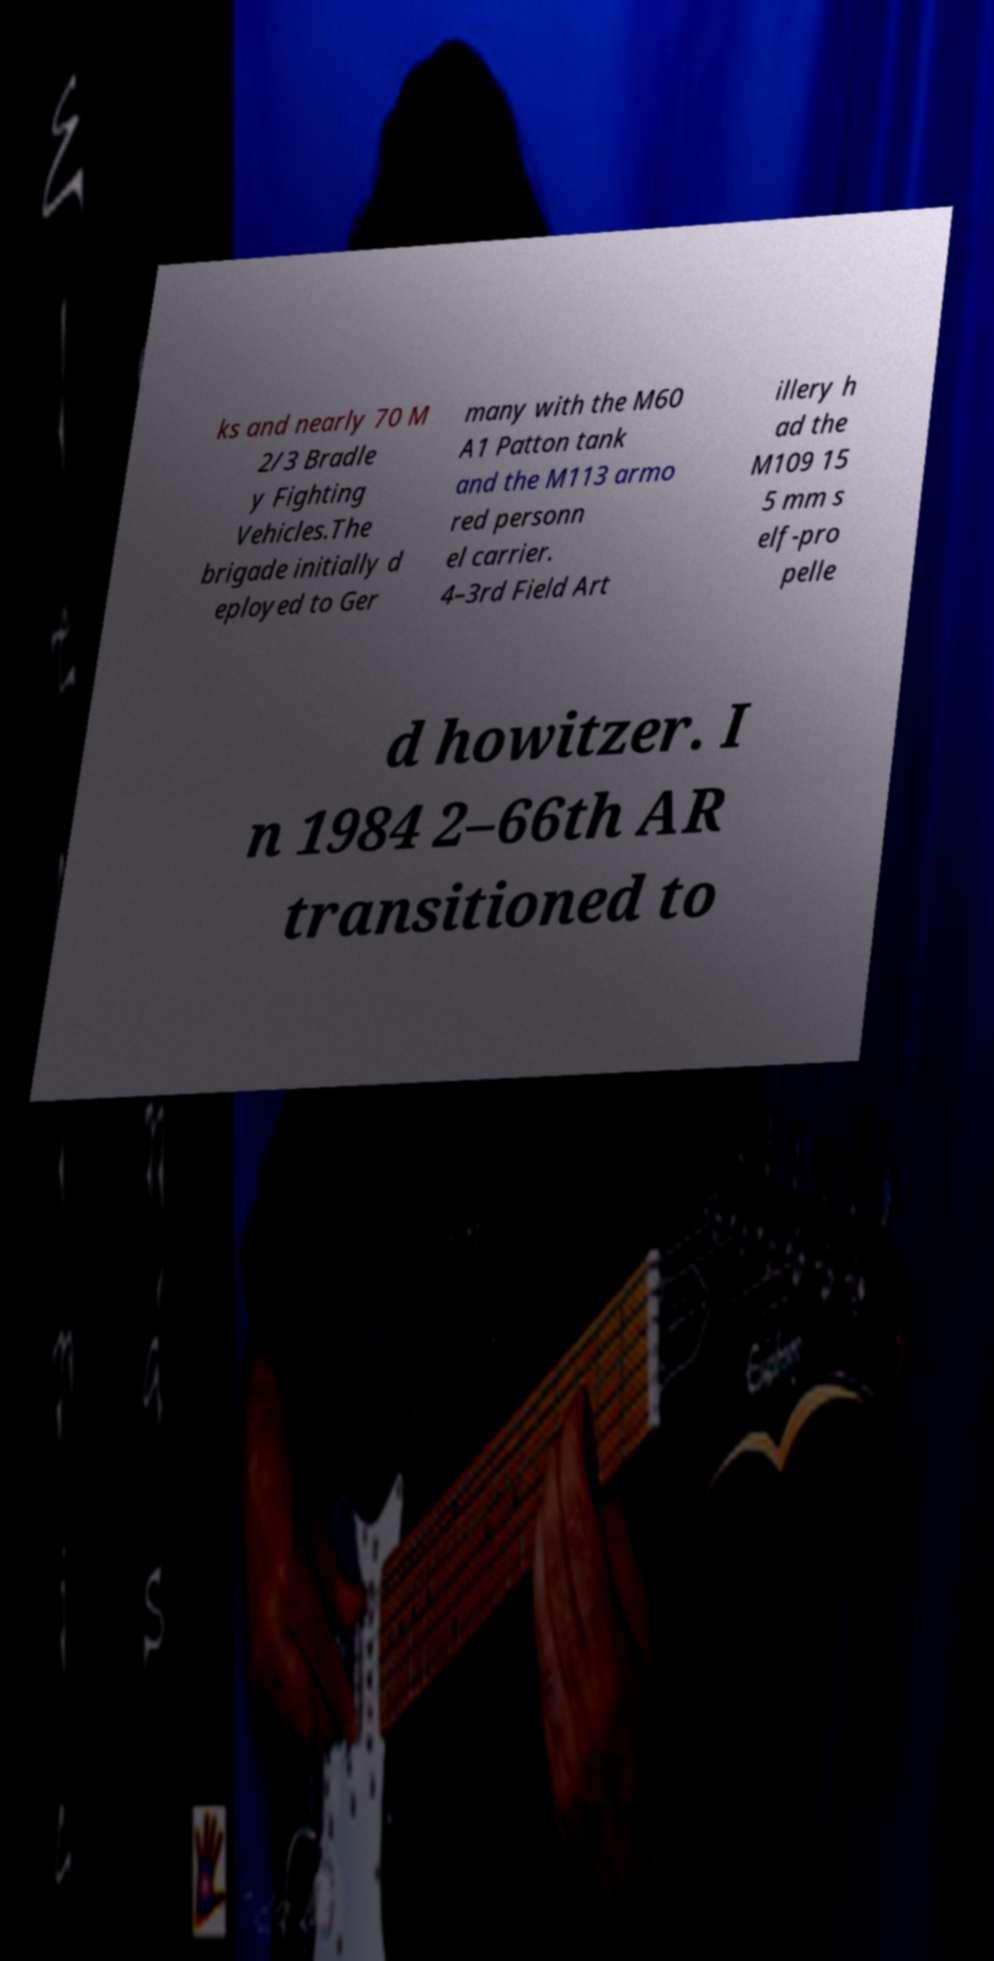Can you read and provide the text displayed in the image?This photo seems to have some interesting text. Can you extract and type it out for me? ks and nearly 70 M 2/3 Bradle y Fighting Vehicles.The brigade initially d eployed to Ger many with the M60 A1 Patton tank and the M113 armo red personn el carrier. 4–3rd Field Art illery h ad the M109 15 5 mm s elf-pro pelle d howitzer. I n 1984 2–66th AR transitioned to 